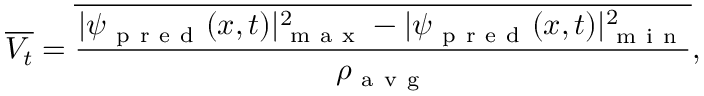<formula> <loc_0><loc_0><loc_500><loc_500>\overline { { V _ { t } } } = \overline { { \frac { | \psi _ { p r e d } ( x , t ) | _ { m a x } ^ { 2 } - | \psi _ { p r e d } ( x , t ) | _ { m i n } ^ { 2 } } { \rho _ { a v g } } } } ,</formula> 